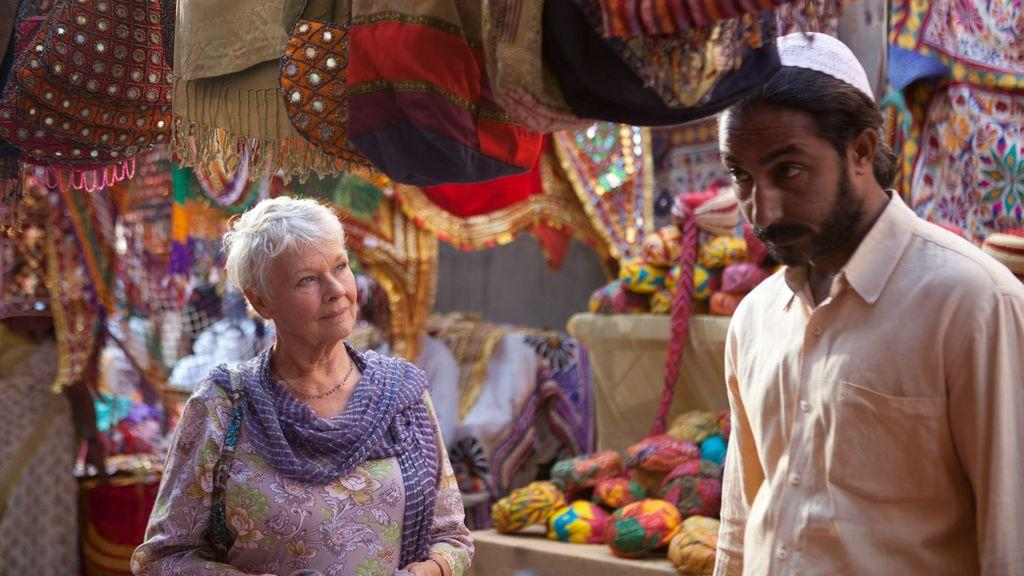How many people are in the image? There is a man and a woman in the image. What are the people in the image wearing? The people in the image are wearing turbans. What can be seen in the image besides the people? There are bags and other objects present in the image. How many caves can be seen in the image? There are no caves present in the image. What is the rate at which the woman is biting the apple in the image? There is no apple or biting action in the image. 